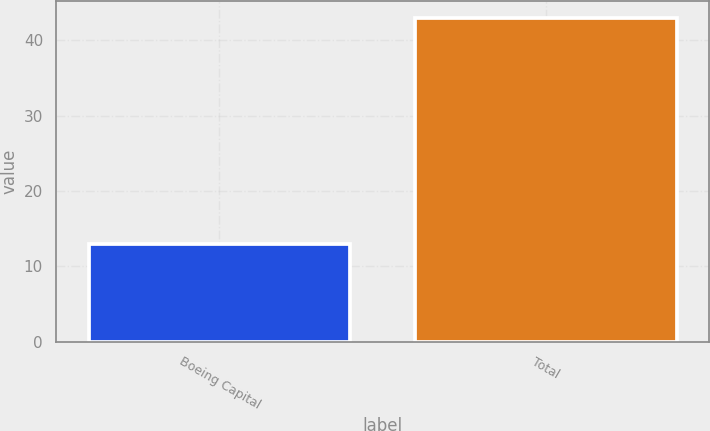Convert chart. <chart><loc_0><loc_0><loc_500><loc_500><bar_chart><fcel>Boeing Capital<fcel>Total<nl><fcel>13<fcel>43<nl></chart> 